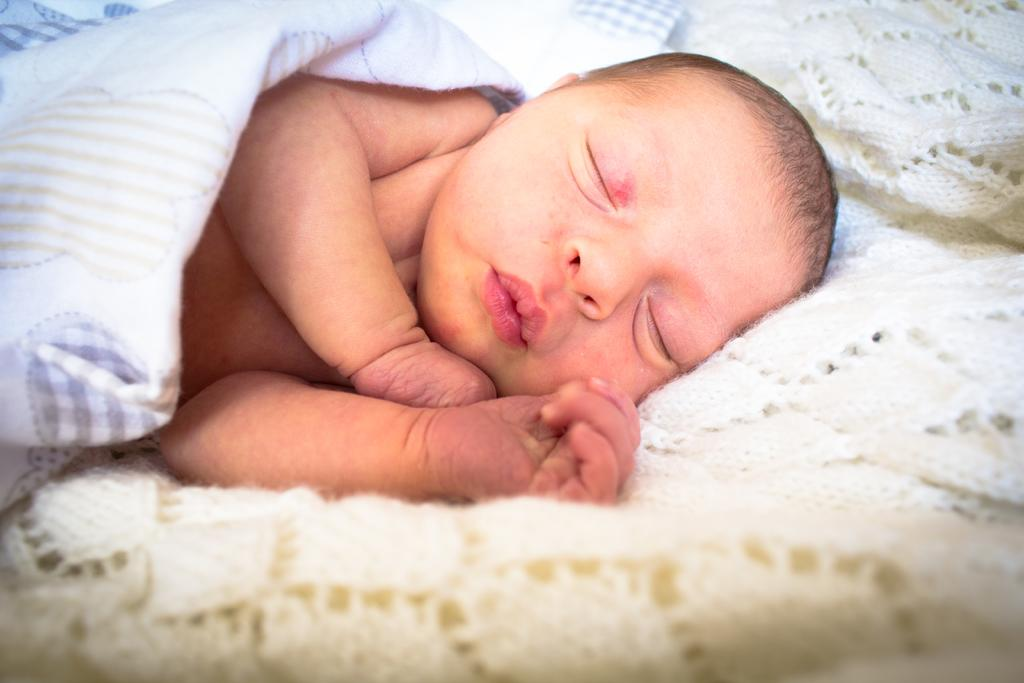What is the main subject of the picture? The main subject of the picture is a baby. What is the baby doing in the image? The baby is sleeping. What is covering the baby in the image? The baby is covered with a white color blanket. What can be seen at the bottom of the image? There is a cream color cloth at the bottom of the image. What type of toys can be seen scattered around the baby in the image? There are no toys visible in the image; the baby is covered with a white color blanket and lying on a cream color cloth. What emotion does the baby seem to be expressing in the image? The baby is sleeping, so it is not expressing any emotions in the image. 